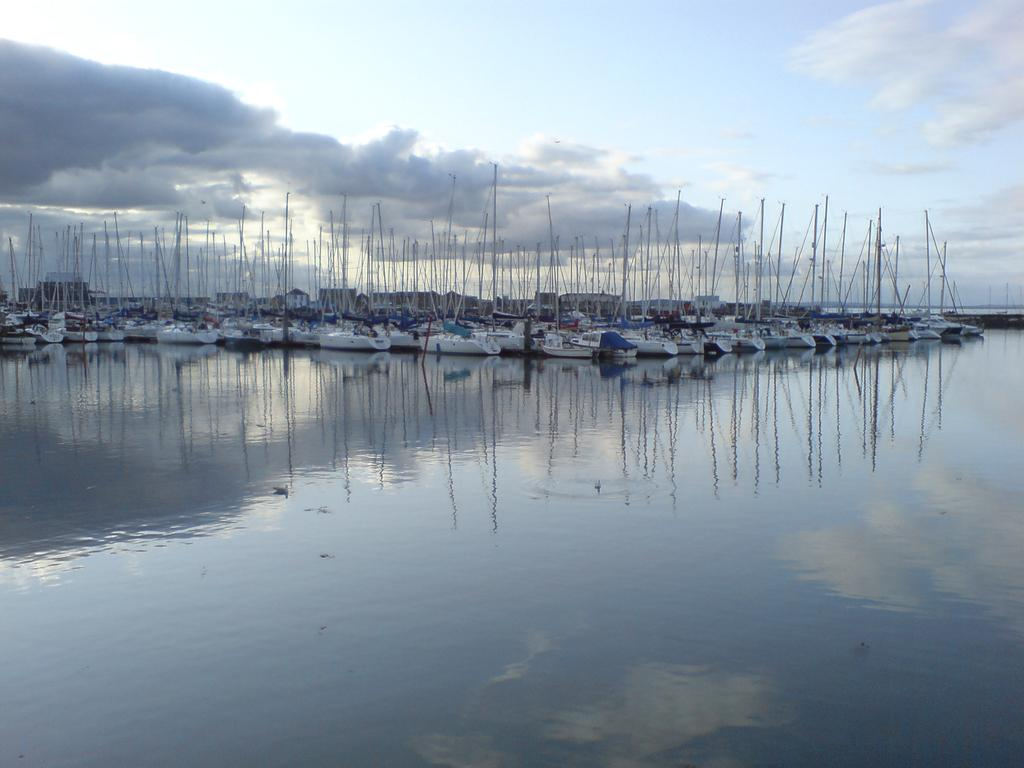What is the main feature of the image? The main feature of the image is a water body. What can be seen in the center of the water body? There are boats in the center of the picture. How would you describe the sky in the image? The sky is cloudy in the image. How many fans are visible in the image? There are no fans present in the image. Is there a chess game being played on the water in the image? There is no chess game being played in the image; it features a water body with boats. 